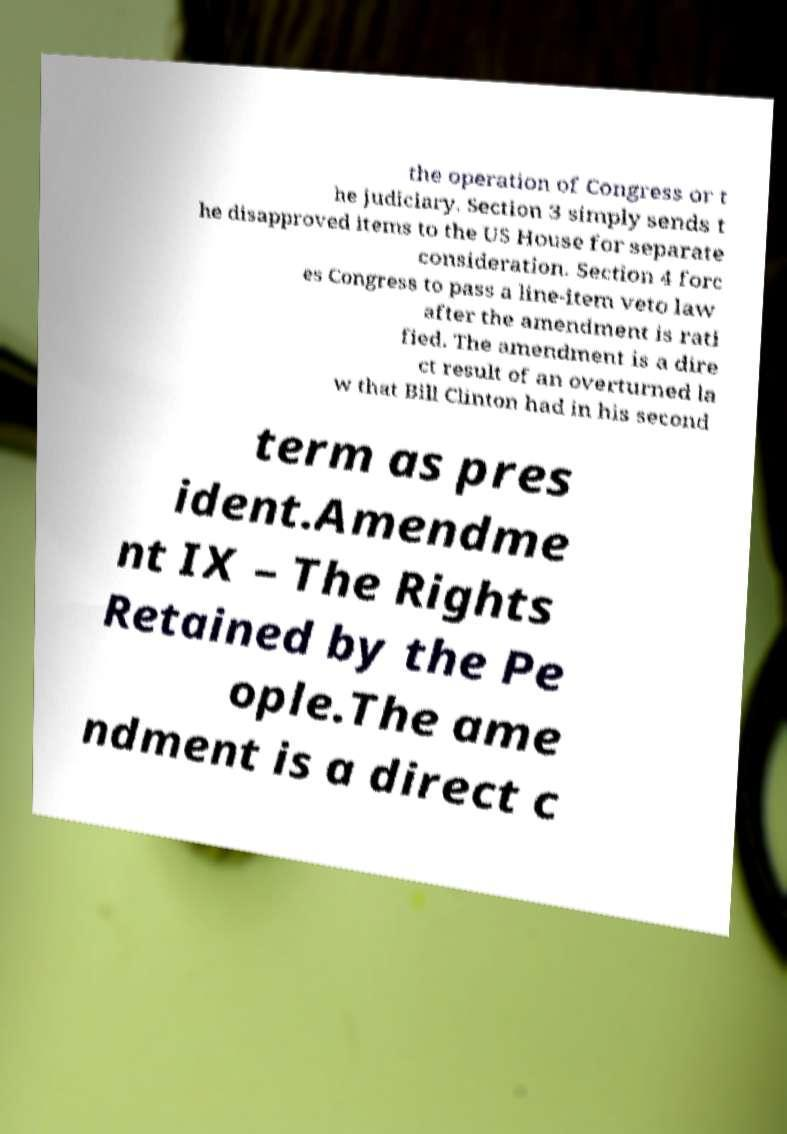Could you assist in decoding the text presented in this image and type it out clearly? the operation of Congress or t he judiciary. Section 3 simply sends t he disapproved items to the US House for separate consideration. Section 4 forc es Congress to pass a line-item veto law after the amendment is rati fied. The amendment is a dire ct result of an overturned la w that Bill Clinton had in his second term as pres ident.Amendme nt IX – The Rights Retained by the Pe ople.The ame ndment is a direct c 